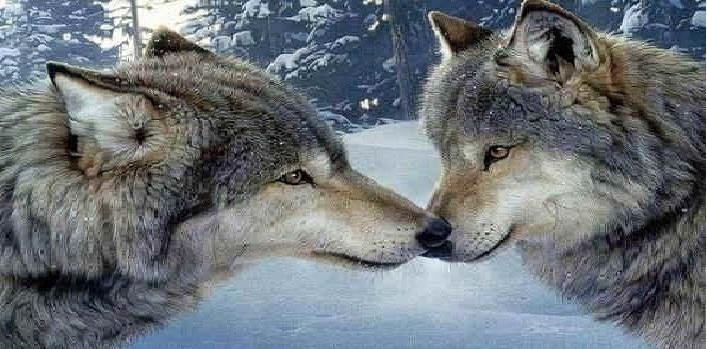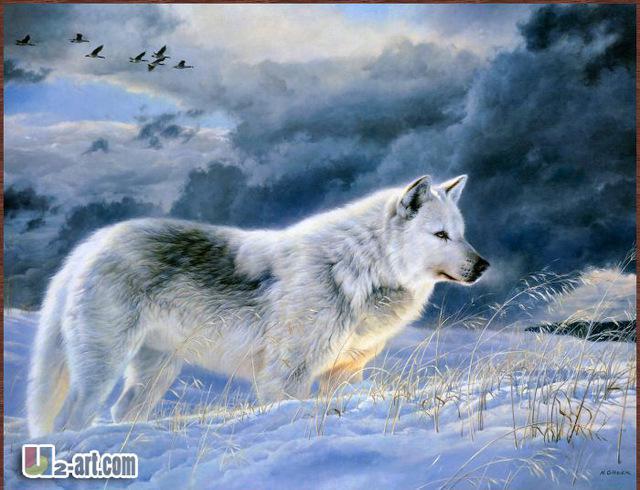The first image is the image on the left, the second image is the image on the right. For the images shown, is this caption "There are 2 wolves facing forward." true? Answer yes or no. No. 